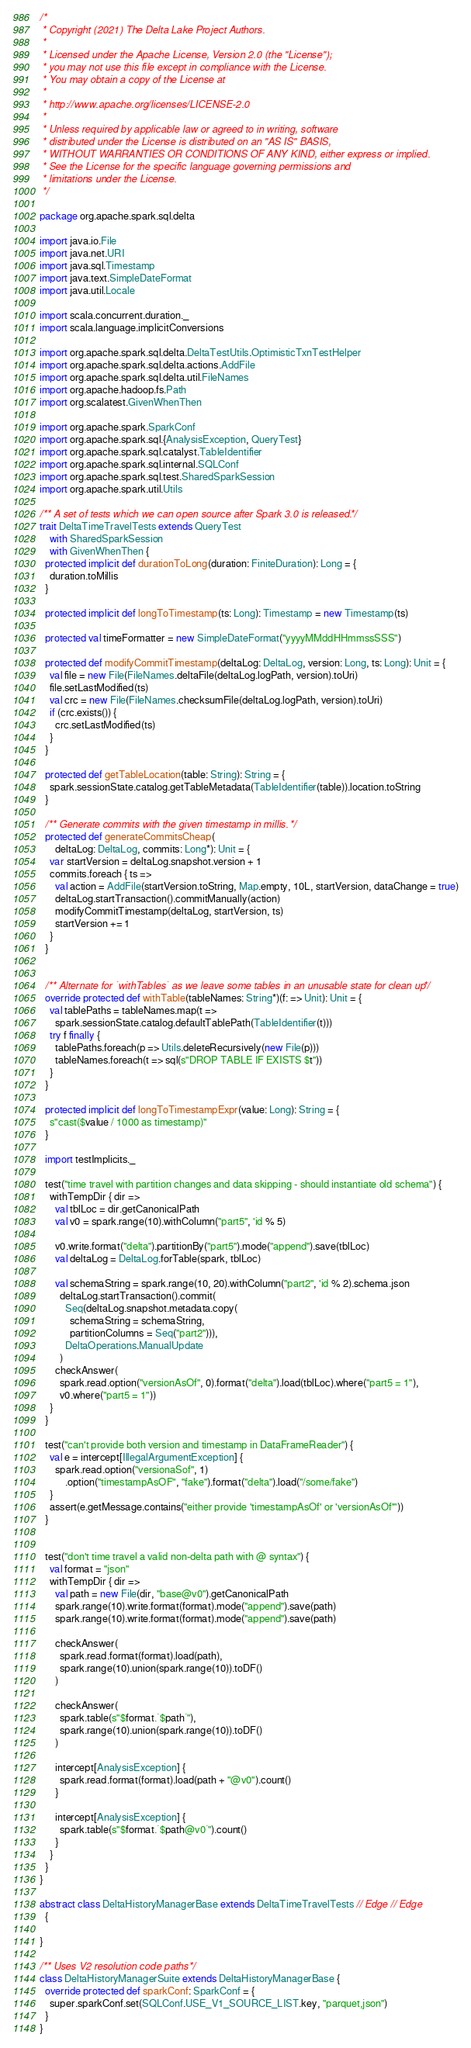Convert code to text. <code><loc_0><loc_0><loc_500><loc_500><_Scala_>/*
 * Copyright (2021) The Delta Lake Project Authors.
 *
 * Licensed under the Apache License, Version 2.0 (the "License");
 * you may not use this file except in compliance with the License.
 * You may obtain a copy of the License at
 *
 * http://www.apache.org/licenses/LICENSE-2.0
 *
 * Unless required by applicable law or agreed to in writing, software
 * distributed under the License is distributed on an "AS IS" BASIS,
 * WITHOUT WARRANTIES OR CONDITIONS OF ANY KIND, either express or implied.
 * See the License for the specific language governing permissions and
 * limitations under the License.
 */

package org.apache.spark.sql.delta

import java.io.File
import java.net.URI
import java.sql.Timestamp
import java.text.SimpleDateFormat
import java.util.Locale

import scala.concurrent.duration._
import scala.language.implicitConversions

import org.apache.spark.sql.delta.DeltaTestUtils.OptimisticTxnTestHelper
import org.apache.spark.sql.delta.actions.AddFile
import org.apache.spark.sql.delta.util.FileNames
import org.apache.hadoop.fs.Path
import org.scalatest.GivenWhenThen

import org.apache.spark.SparkConf
import org.apache.spark.sql.{AnalysisException, QueryTest}
import org.apache.spark.sql.catalyst.TableIdentifier
import org.apache.spark.sql.internal.SQLConf
import org.apache.spark.sql.test.SharedSparkSession
import org.apache.spark.util.Utils

/** A set of tests which we can open source after Spark 3.0 is released. */
trait DeltaTimeTravelTests extends QueryTest
    with SharedSparkSession
    with GivenWhenThen {
  protected implicit def durationToLong(duration: FiniteDuration): Long = {
    duration.toMillis
  }

  protected implicit def longToTimestamp(ts: Long): Timestamp = new Timestamp(ts)

  protected val timeFormatter = new SimpleDateFormat("yyyyMMddHHmmssSSS")

  protected def modifyCommitTimestamp(deltaLog: DeltaLog, version: Long, ts: Long): Unit = {
    val file = new File(FileNames.deltaFile(deltaLog.logPath, version).toUri)
    file.setLastModified(ts)
    val crc = new File(FileNames.checksumFile(deltaLog.logPath, version).toUri)
    if (crc.exists()) {
      crc.setLastModified(ts)
    }
  }

  protected def getTableLocation(table: String): String = {
    spark.sessionState.catalog.getTableMetadata(TableIdentifier(table)).location.toString
  }

  /** Generate commits with the given timestamp in millis. */
  protected def generateCommitsCheap(
      deltaLog: DeltaLog, commits: Long*): Unit = {
    var startVersion = deltaLog.snapshot.version + 1
    commits.foreach { ts =>
      val action = AddFile(startVersion.toString, Map.empty, 10L, startVersion, dataChange = true)
      deltaLog.startTransaction().commitManually(action)
      modifyCommitTimestamp(deltaLog, startVersion, ts)
      startVersion += 1
    }
  }


  /** Alternate for `withTables` as we leave some tables in an unusable state for clean up */
  override protected def withTable(tableNames: String*)(f: => Unit): Unit = {
    val tablePaths = tableNames.map(t =>
      spark.sessionState.catalog.defaultTablePath(TableIdentifier(t)))
    try f finally {
      tablePaths.foreach(p => Utils.deleteRecursively(new File(p)))
      tableNames.foreach(t => sql(s"DROP TABLE IF EXISTS $t"))
    }
  }

  protected implicit def longToTimestampExpr(value: Long): String = {
    s"cast($value / 1000 as timestamp)"
  }

  import testImplicits._

  test("time travel with partition changes and data skipping - should instantiate old schema") {
    withTempDir { dir =>
      val tblLoc = dir.getCanonicalPath
      val v0 = spark.range(10).withColumn("part5", 'id % 5)

      v0.write.format("delta").partitionBy("part5").mode("append").save(tblLoc)
      val deltaLog = DeltaLog.forTable(spark, tblLoc)

      val schemaString = spark.range(10, 20).withColumn("part2", 'id % 2).schema.json
        deltaLog.startTransaction().commit(
          Seq(deltaLog.snapshot.metadata.copy(
            schemaString = schemaString,
            partitionColumns = Seq("part2"))),
          DeltaOperations.ManualUpdate
        )
      checkAnswer(
        spark.read.option("versionAsOf", 0).format("delta").load(tblLoc).where("part5 = 1"),
        v0.where("part5 = 1"))
    }
  }

  test("can't provide both version and timestamp in DataFrameReader") {
    val e = intercept[IllegalArgumentException] {
      spark.read.option("versionaSof", 1)
          .option("timestampAsOF", "fake").format("delta").load("/some/fake")
    }
    assert(e.getMessage.contains("either provide 'timestampAsOf' or 'versionAsOf'"))
  }


  test("don't time travel a valid non-delta path with @ syntax") {
    val format = "json"
    withTempDir { dir =>
      val path = new File(dir, "base@v0").getCanonicalPath
      spark.range(10).write.format(format).mode("append").save(path)
      spark.range(10).write.format(format).mode("append").save(path)

      checkAnswer(
        spark.read.format(format).load(path),
        spark.range(10).union(spark.range(10)).toDF()
      )

      checkAnswer(
        spark.table(s"$format.`$path`"),
        spark.range(10).union(spark.range(10)).toDF()
      )

      intercept[AnalysisException] {
        spark.read.format(format).load(path + "@v0").count()
      }

      intercept[AnalysisException] {
        spark.table(s"$format.`$path@v0`").count()
      }
    }
  }
}

abstract class DeltaHistoryManagerBase extends DeltaTimeTravelTests // Edge // Edge
  {

}

/** Uses V2 resolution code paths */
class DeltaHistoryManagerSuite extends DeltaHistoryManagerBase {
  override protected def sparkConf: SparkConf = {
    super.sparkConf.set(SQLConf.USE_V1_SOURCE_LIST.key, "parquet,json")
  }
}
</code> 